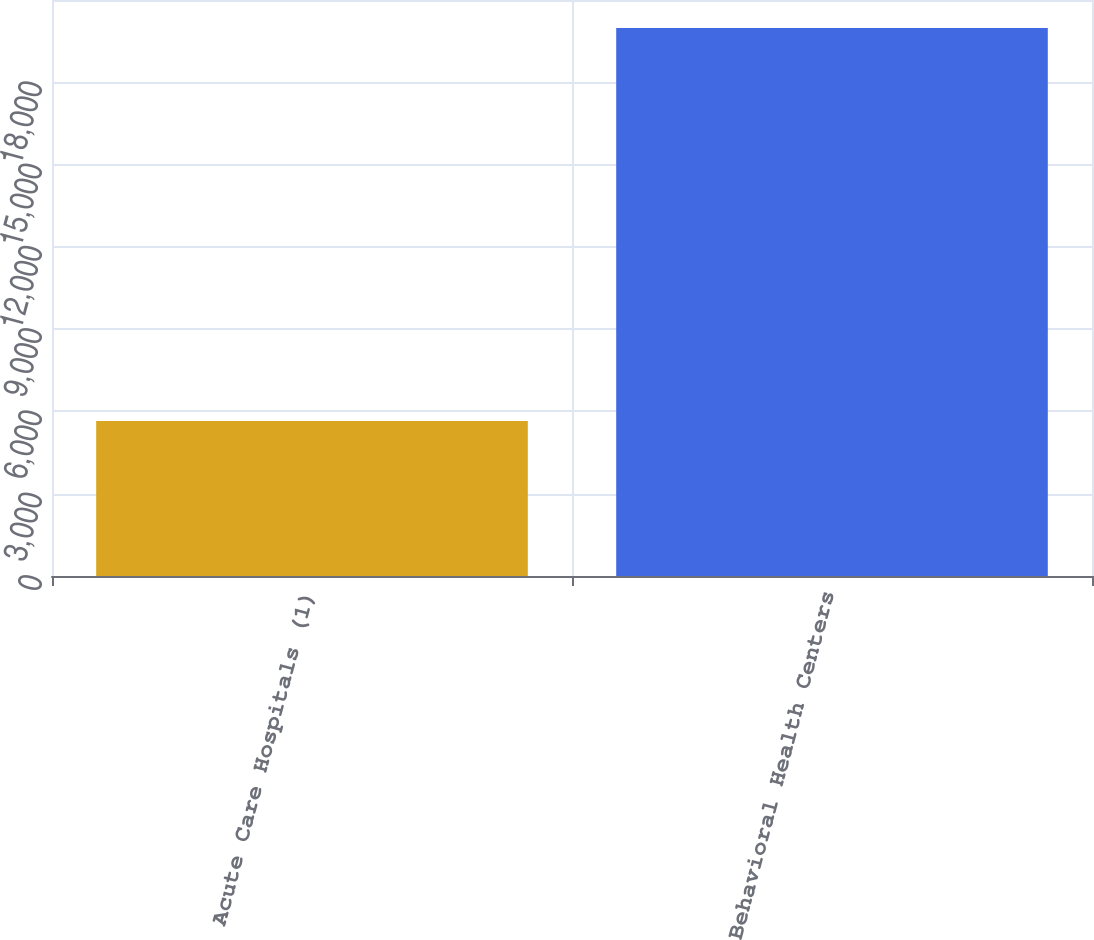Convert chart to OTSL. <chart><loc_0><loc_0><loc_500><loc_500><bar_chart><fcel>Acute Care Hospitals (1)<fcel>Behavioral Health Centers<nl><fcel>5652<fcel>19975<nl></chart> 